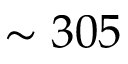<formula> <loc_0><loc_0><loc_500><loc_500>\sim 3 0 5</formula> 